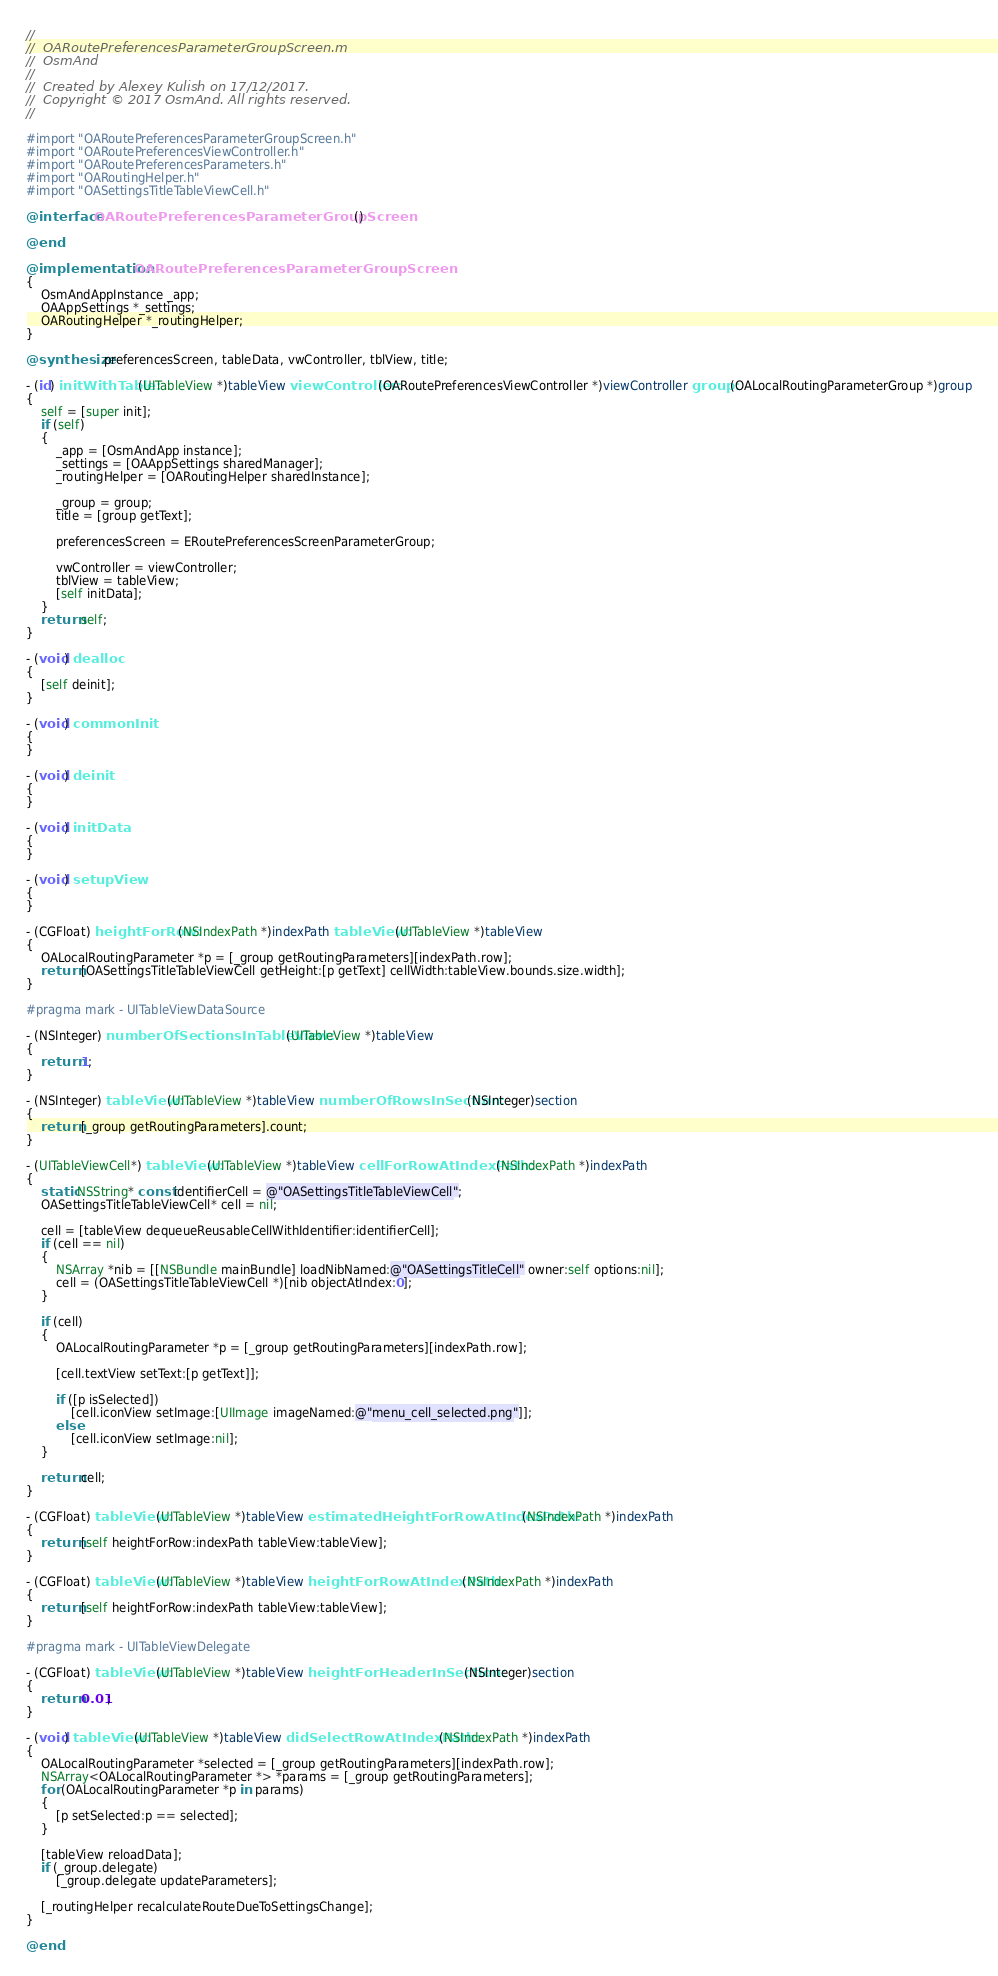Convert code to text. <code><loc_0><loc_0><loc_500><loc_500><_ObjectiveC_>//
//  OARoutePreferencesParameterGroupScreen.m
//  OsmAnd
//
//  Created by Alexey Kulish on 17/12/2017.
//  Copyright © 2017 OsmAnd. All rights reserved.
//

#import "OARoutePreferencesParameterGroupScreen.h"
#import "OARoutePreferencesViewController.h"
#import "OARoutePreferencesParameters.h"
#import "OARoutingHelper.h"
#import "OASettingsTitleTableViewCell.h"

@interface OARoutePreferencesParameterGroupScreen ()

@end

@implementation OARoutePreferencesParameterGroupScreen
{
    OsmAndAppInstance _app;
    OAAppSettings *_settings;
    OARoutingHelper *_routingHelper;
}

@synthesize preferencesScreen, tableData, vwController, tblView, title;

- (id) initWithTable:(UITableView *)tableView viewController:(OARoutePreferencesViewController *)viewController group:(OALocalRoutingParameterGroup *)group
{
    self = [super init];
    if (self)
    {
        _app = [OsmAndApp instance];
        _settings = [OAAppSettings sharedManager];
        _routingHelper = [OARoutingHelper sharedInstance];
        
        _group = group;
        title = [group getText];
        
        preferencesScreen = ERoutePreferencesScreenParameterGroup;
        
        vwController = viewController;
        tblView = tableView;
        [self initData];
    }
    return self;
}

- (void) dealloc
{
    [self deinit];
}

- (void) commonInit
{
}

- (void) deinit
{
}

- (void) initData
{
}

- (void) setupView
{
}

- (CGFloat) heightForRow:(NSIndexPath *)indexPath tableView:(UITableView *)tableView
{
    OALocalRoutingParameter *p = [_group getRoutingParameters][indexPath.row];
    return [OASettingsTitleTableViewCell getHeight:[p getText] cellWidth:tableView.bounds.size.width];
}

#pragma mark - UITableViewDataSource

- (NSInteger) numberOfSectionsInTableView:(UITableView *)tableView
{
    return 1;
}

- (NSInteger) tableView:(UITableView *)tableView numberOfRowsInSection:(NSInteger)section
{
    return [_group getRoutingParameters].count;
}

- (UITableViewCell*) tableView:(UITableView *)tableView cellForRowAtIndexPath:(NSIndexPath *)indexPath
{
    static NSString* const identifierCell = @"OASettingsTitleTableViewCell";
    OASettingsTitleTableViewCell* cell = nil;
    
    cell = [tableView dequeueReusableCellWithIdentifier:identifierCell];
    if (cell == nil)
    {
        NSArray *nib = [[NSBundle mainBundle] loadNibNamed:@"OASettingsTitleCell" owner:self options:nil];
        cell = (OASettingsTitleTableViewCell *)[nib objectAtIndex:0];
    }
    
    if (cell)
    {
        OALocalRoutingParameter *p = [_group getRoutingParameters][indexPath.row];
        
        [cell.textView setText:[p getText]];
        
        if ([p isSelected])
            [cell.iconView setImage:[UIImage imageNamed:@"menu_cell_selected.png"]];
        else
            [cell.iconView setImage:nil];
    }
    
    return cell;
}

- (CGFloat) tableView:(UITableView *)tableView estimatedHeightForRowAtIndexPath:(NSIndexPath *)indexPath
{
    return [self heightForRow:indexPath tableView:tableView];
}

- (CGFloat) tableView:(UITableView *)tableView heightForRowAtIndexPath:(NSIndexPath *)indexPath
{
    return [self heightForRow:indexPath tableView:tableView];
}

#pragma mark - UITableViewDelegate

- (CGFloat) tableView:(UITableView *)tableView heightForHeaderInSection:(NSInteger)section
{
    return 0.01;
}

- (void) tableView:(UITableView *)tableView didSelectRowAtIndexPath:(NSIndexPath *)indexPath
{
    OALocalRoutingParameter *selected = [_group getRoutingParameters][indexPath.row];
    NSArray<OALocalRoutingParameter *> *params = [_group getRoutingParameters];
    for (OALocalRoutingParameter *p in params)
    {
        [p setSelected:p == selected];
    }
    
    [tableView reloadData];
    if (_group.delegate)
        [_group.delegate updateParameters];
    
    [_routingHelper recalculateRouteDueToSettingsChange];
}

@end
</code> 